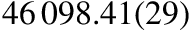Convert formula to latex. <formula><loc_0><loc_0><loc_500><loc_500>4 6 \, 0 9 8 . 4 1 ( 2 9 )</formula> 